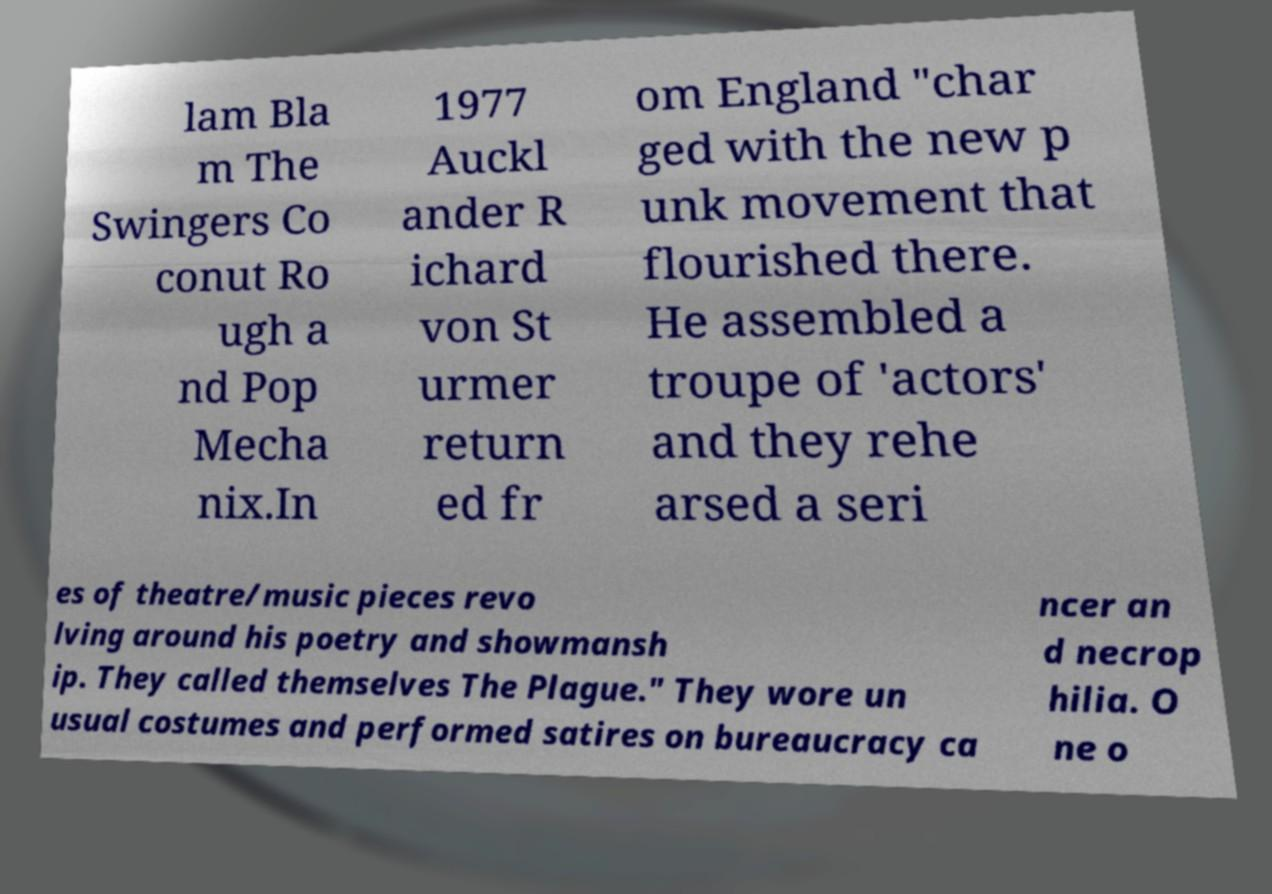I need the written content from this picture converted into text. Can you do that? lam Bla m The Swingers Co conut Ro ugh a nd Pop Mecha nix.In 1977 Auckl ander R ichard von St urmer return ed fr om England "char ged with the new p unk movement that flourished there. He assembled a troupe of 'actors' and they rehe arsed a seri es of theatre/music pieces revo lving around his poetry and showmansh ip. They called themselves The Plague." They wore un usual costumes and performed satires on bureaucracy ca ncer an d necrop hilia. O ne o 